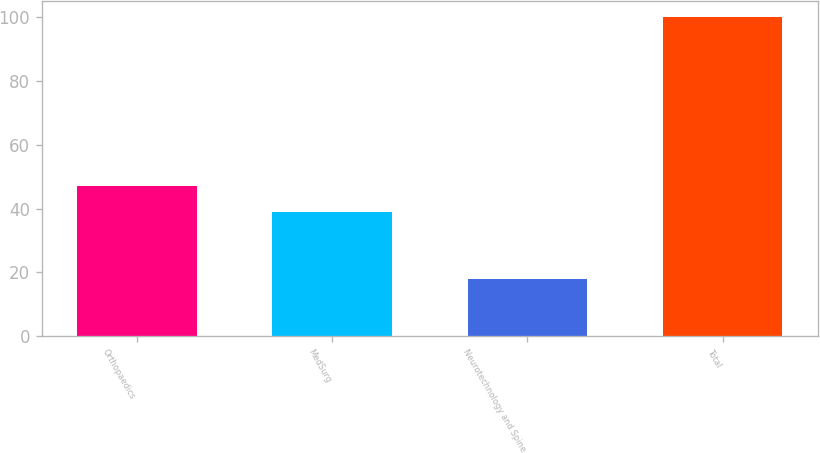<chart> <loc_0><loc_0><loc_500><loc_500><bar_chart><fcel>Orthopaedics<fcel>MedSurg<fcel>Neurotechnology and Spine<fcel>Total<nl><fcel>47.2<fcel>39<fcel>18<fcel>100<nl></chart> 